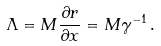<formula> <loc_0><loc_0><loc_500><loc_500>\Lambda = M \frac { \partial r } { \partial x } = M \gamma ^ { - 1 } \, .</formula> 